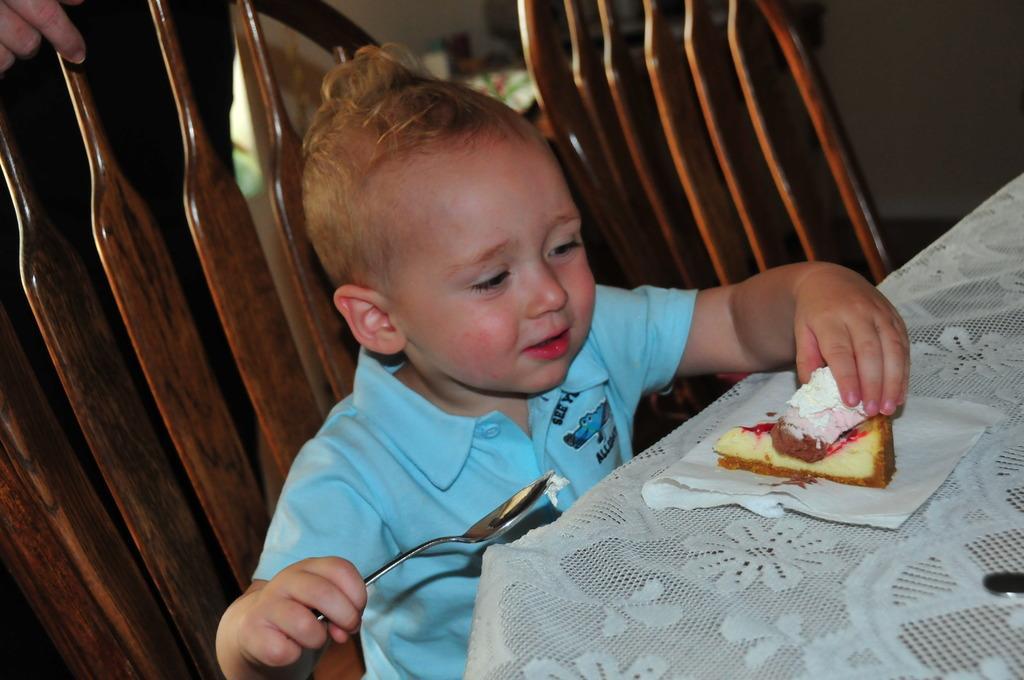Describe this image in one or two sentences. In this image i can see a child holding a spoon and a cake in his hands and in the background i can see a hand of other person. 